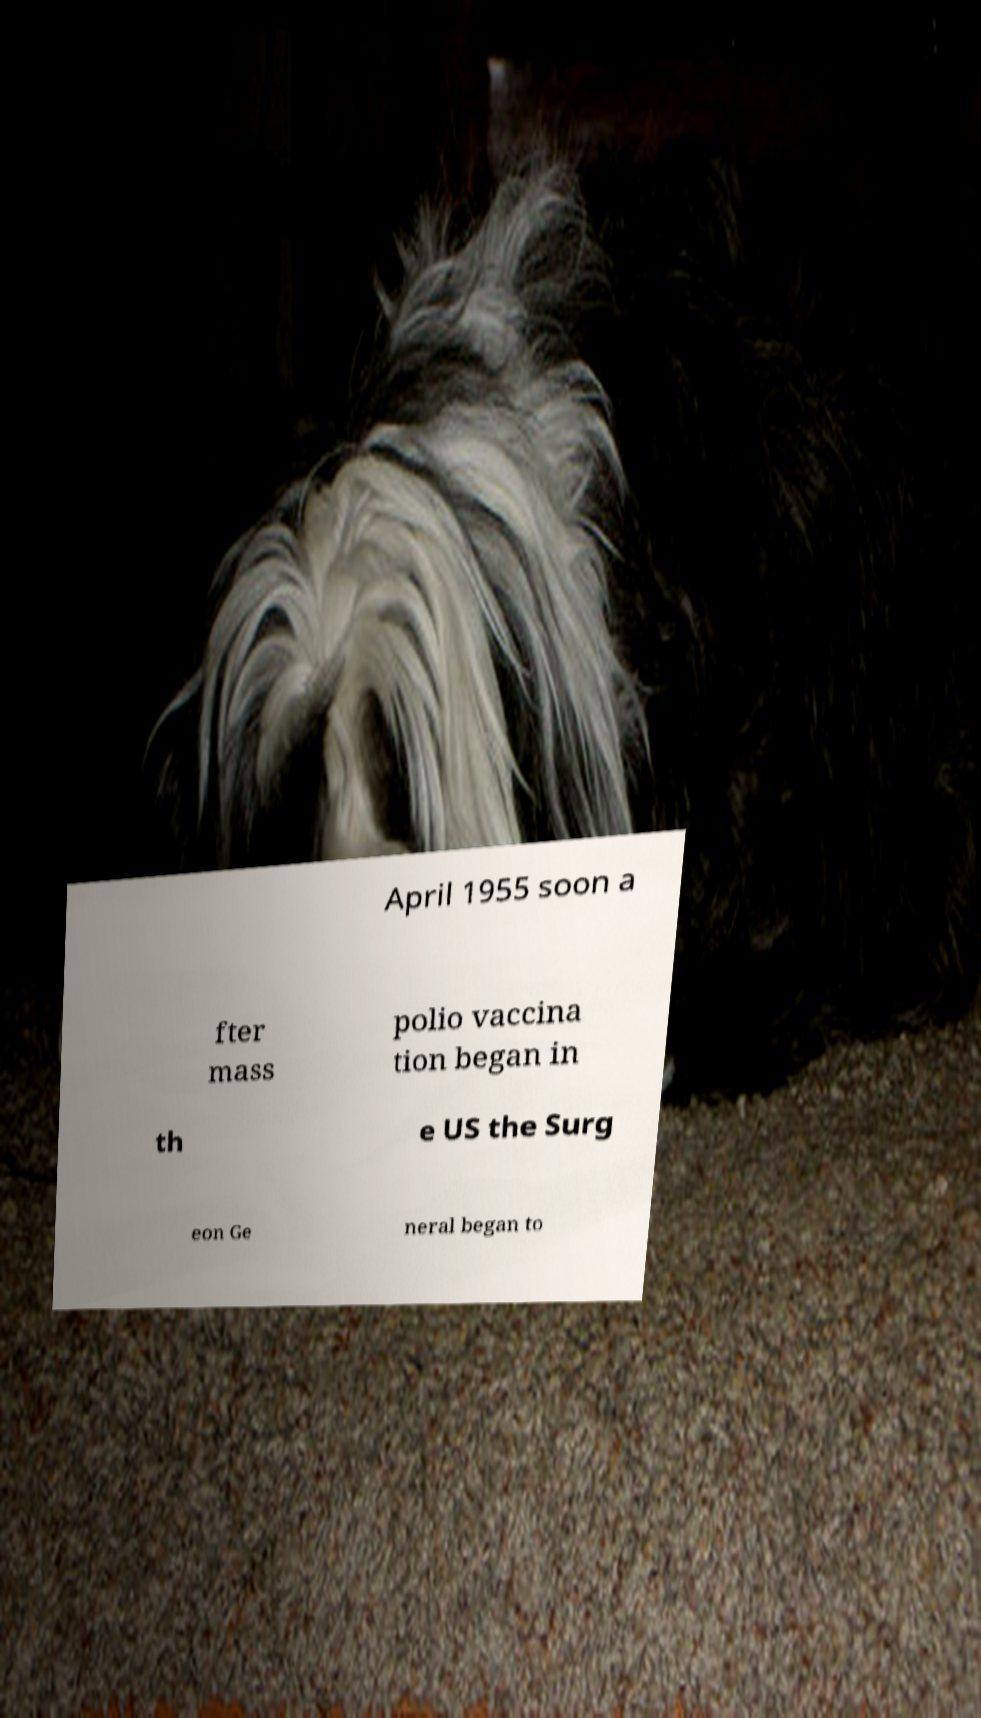I need the written content from this picture converted into text. Can you do that? April 1955 soon a fter mass polio vaccina tion began in th e US the Surg eon Ge neral began to 